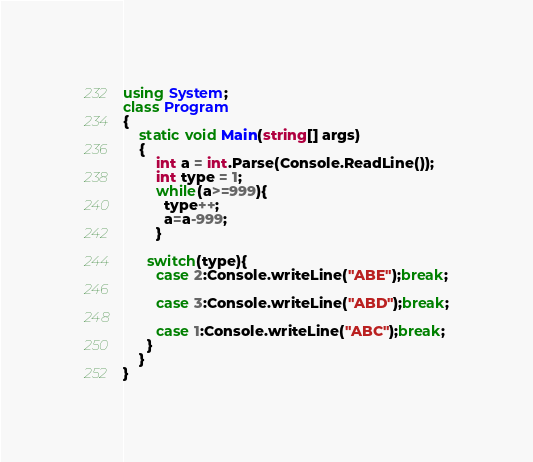<code> <loc_0><loc_0><loc_500><loc_500><_C#_>using System;
class Program
{
    static void Main(string[] args)
    {
        int a = int.Parse(Console.ReadLine());
        int type = 1;
        while(a>=999){
          type++;
          a=a-999;
        }
      
      switch(type){
        case 2:Console.writeLine("ABE");break;
      
        case 3:Console.writeLine("ABD");break;
      
        case 1:Console.writeLine("ABC");break;
      }
    }
}</code> 